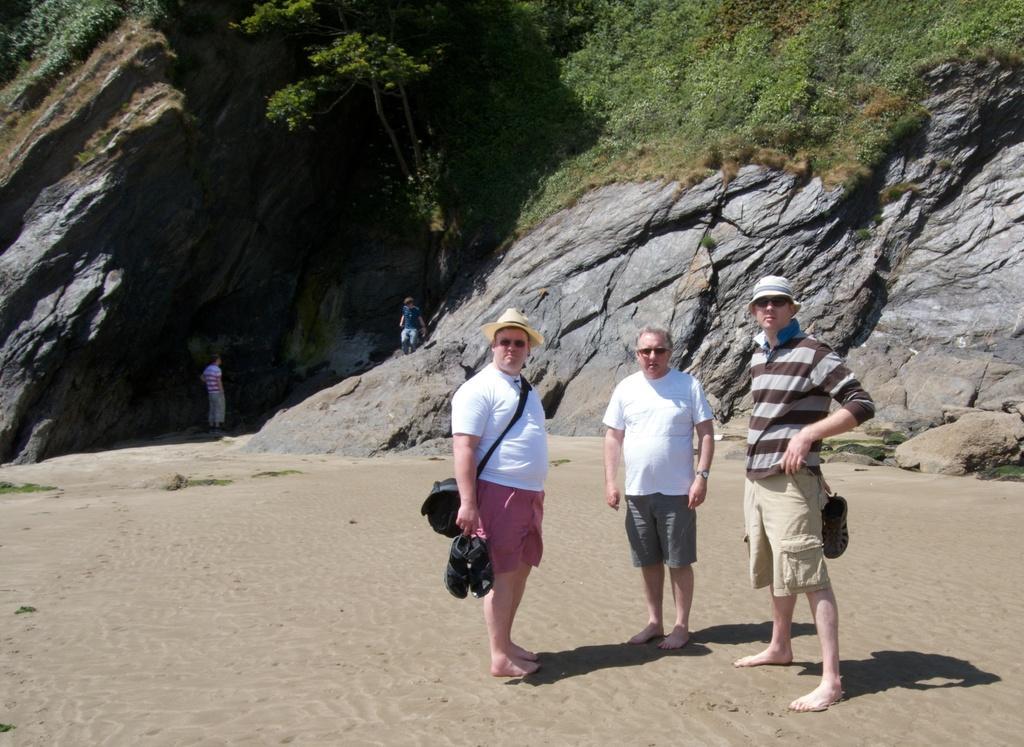How would you summarize this image in a sentence or two? In the image I can see people are standing among them some are carrying bags and wearing hats. I can also see the grass, plants and some other objects. 